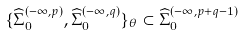<formula> <loc_0><loc_0><loc_500><loc_500>\{ \widehat { \Sigma } _ { 0 } ^ { ( - \infty , p ) } , \widehat { \Sigma } _ { 0 } ^ { ( - \infty , q ) } \} _ { \theta } \subset \widehat { \Sigma } _ { 0 } ^ { ( - \infty , p + q - 1 ) }</formula> 